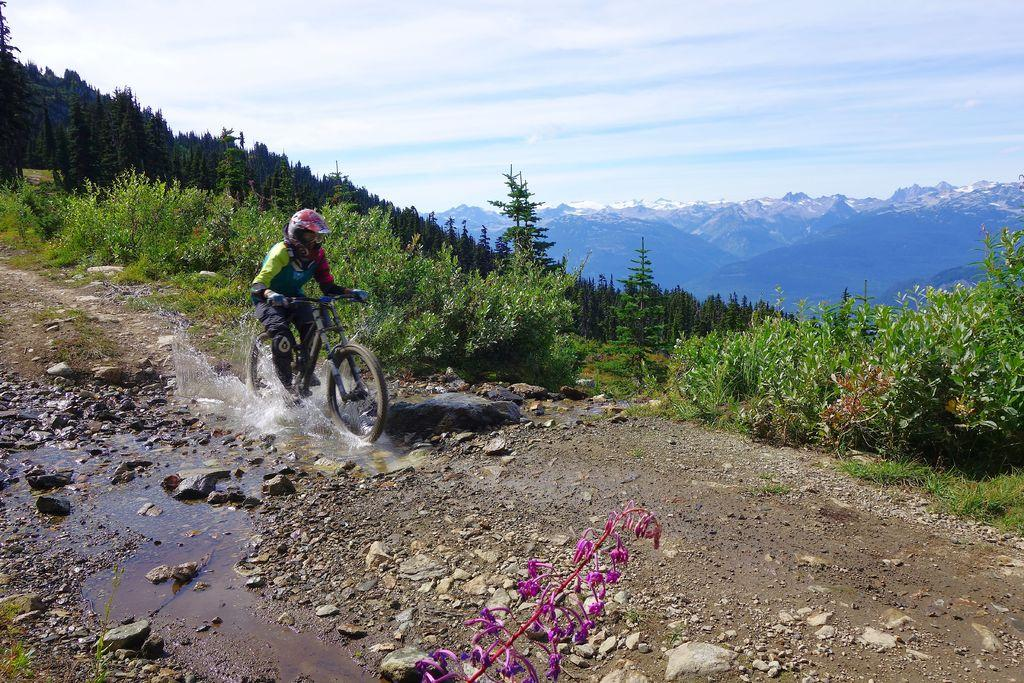What is the person in the image doing? The person is riding a bicycle in the image. What safety precaution is the person taking while riding the bicycle? The person is wearing a helmet. What type of terrain can be seen in the image? There is water, rocks, and trees visible in the image. What can be seen in the background of the image? There are hills and clouds in the background of the image. What type of bit is the person using to improve the acoustics of the bicycle in the image? There is no bit or acoustics-related equipment present in the image; the person is simply riding a bicycle. How does the person plan to travel to space while riding the bicycle in the image? There is no indication of space travel or any related equipment in the image; the person is riding a bicycle on Earth. 